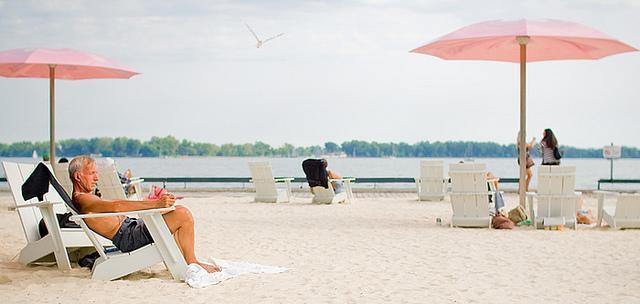How many umbrellas are there?
Give a very brief answer. 2. How many chairs are visible?
Give a very brief answer. 3. 